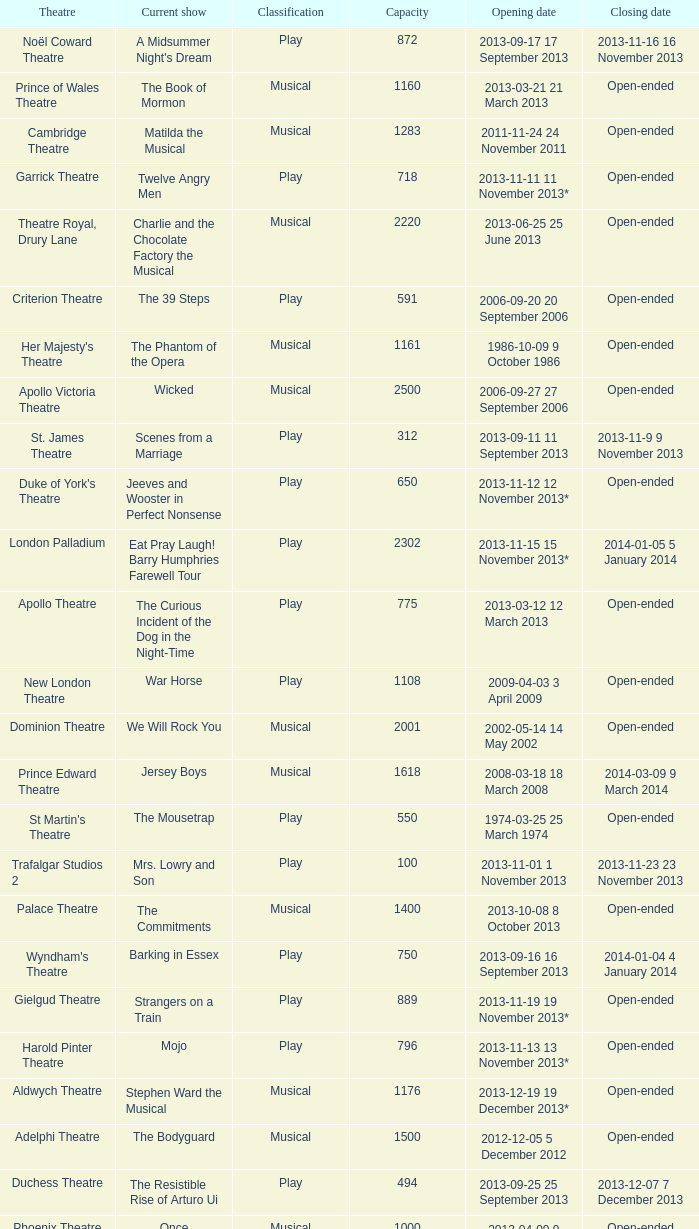What is the opening date of the musical at the adelphi theatre? 2012-12-05 5 December 2012. 